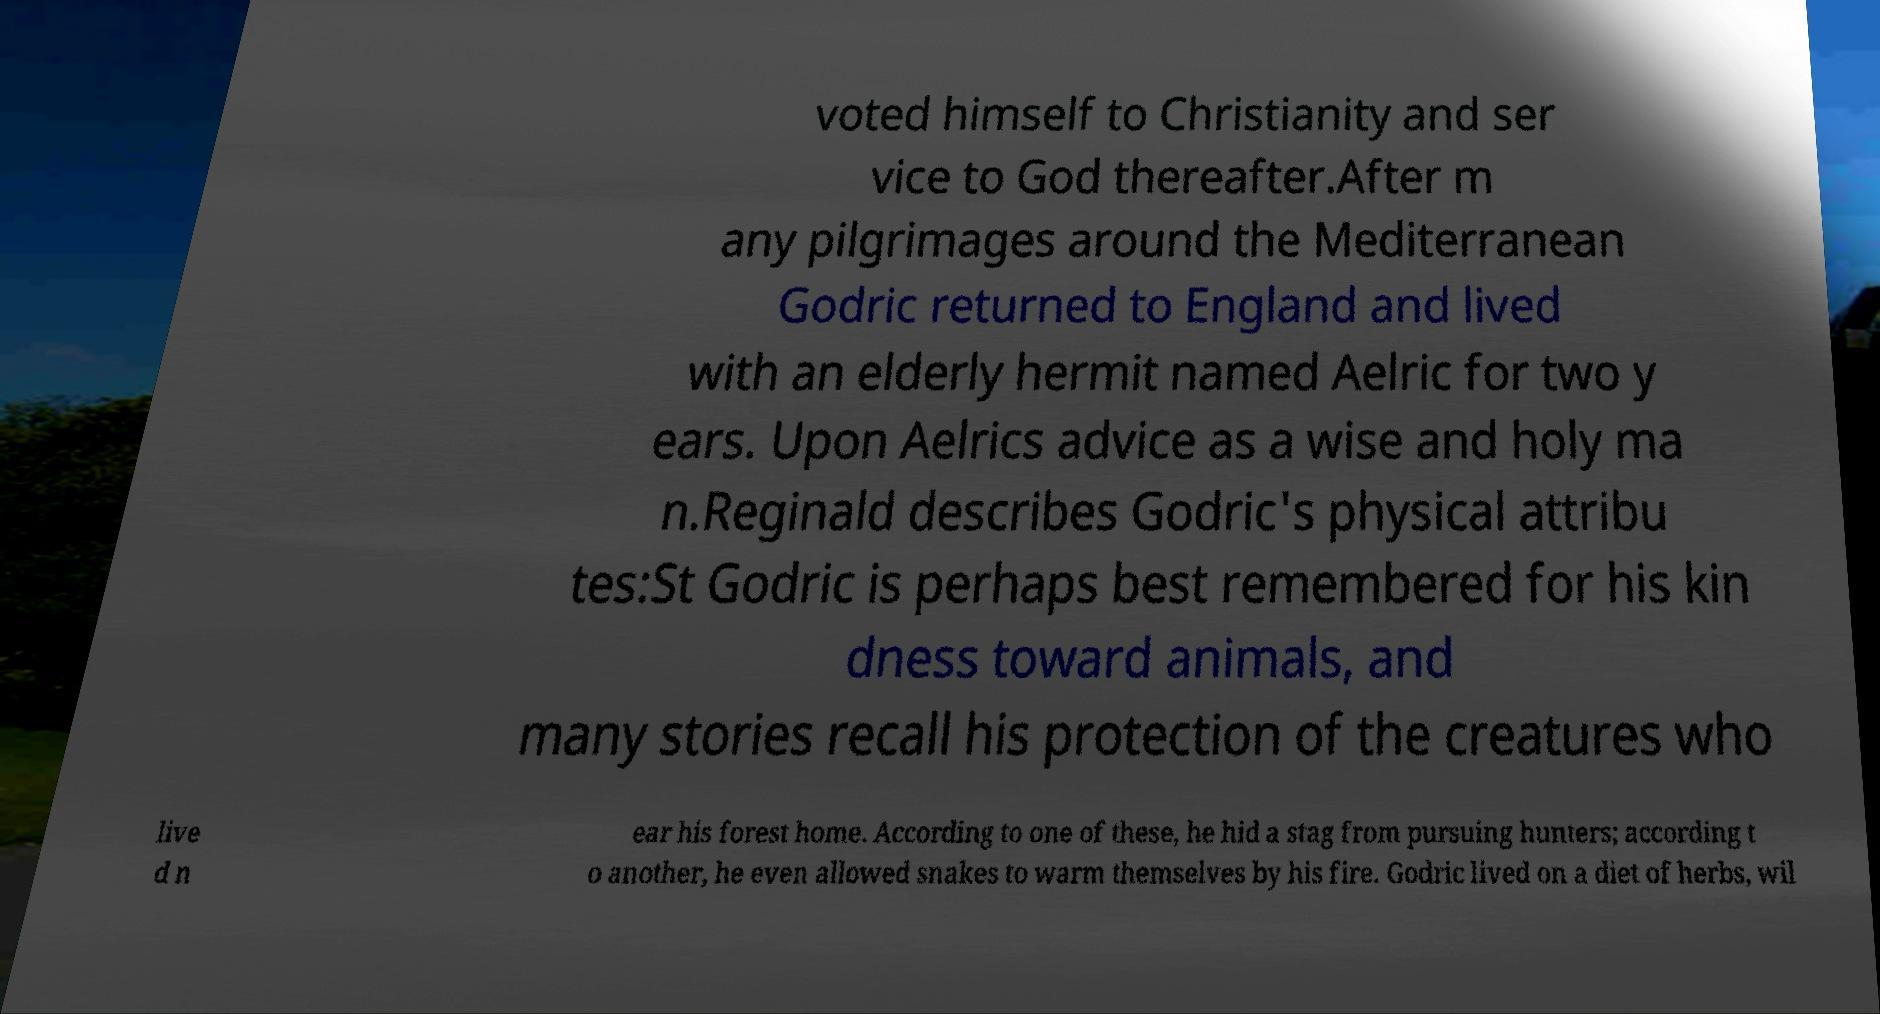There's text embedded in this image that I need extracted. Can you transcribe it verbatim? voted himself to Christianity and ser vice to God thereafter.After m any pilgrimages around the Mediterranean Godric returned to England and lived with an elderly hermit named Aelric for two y ears. Upon Aelrics advice as a wise and holy ma n.Reginald describes Godric's physical attribu tes:St Godric is perhaps best remembered for his kin dness toward animals, and many stories recall his protection of the creatures who live d n ear his forest home. According to one of these, he hid a stag from pursuing hunters; according t o another, he even allowed snakes to warm themselves by his fire. Godric lived on a diet of herbs, wil 